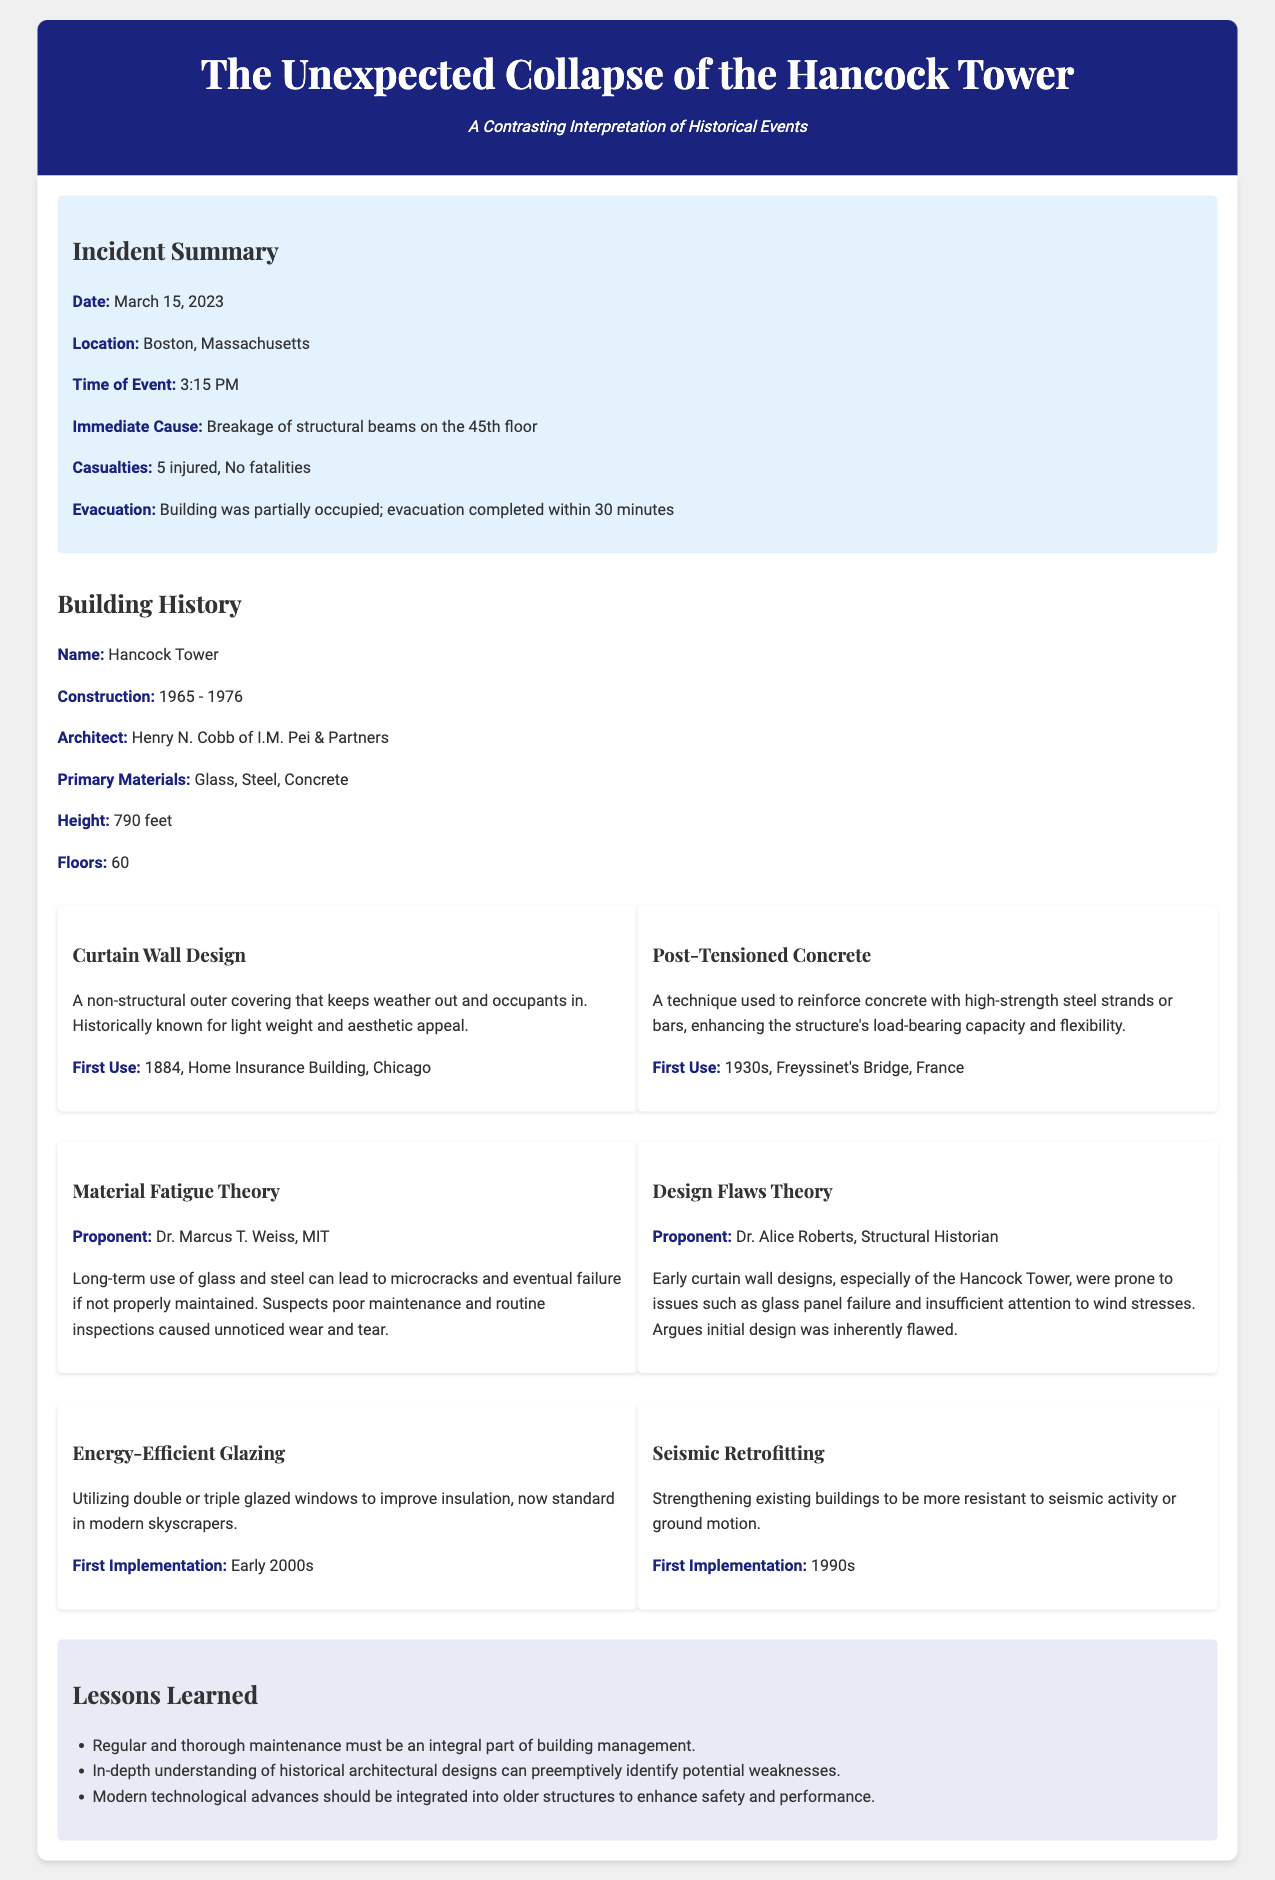What was the date of the incident? The date mentioned in the incident report is March 15, 2023.
Answer: March 15, 2023 Who was the architect of the Hancock Tower? The document states that the architect is Henry N. Cobb of I.M. Pei & Partners.
Answer: Henry N. Cobb What was the immediate cause of the collapse? According to the report, the immediate cause was the breakage of structural beams on the 45th floor.
Answer: Breakage of structural beams on the 45th floor What theory does Dr. Marcus T. Weiss propose? The document indicates that Dr. Marcus T. Weiss supports the Material Fatigue Theory.
Answer: Material Fatigue Theory What were the primary materials used in the construction of the Hancock Tower? The report mentions that the primary materials were glass, steel, and concrete.
Answer: Glass, Steel, Concrete Which modern influence first implemented in the early 2000s is mentioned in the report? The report discusses energy-efficient glazing as a modern influence first implemented in the early 2000s.
Answer: Energy-Efficient Glazing What was the total number of casualties reported? The incident report specifies that there were 5 injured, with no fatalities reported.
Answer: 5 injured What is one lesson learned highlighted in the document? The report highlights that regular and thorough maintenance must be an integral part of building management as a lesson learned.
Answer: Regular and thorough maintenance Which historical technique was first used in the Home Insurance Building? According to the document, the curtain wall design was first used in the Home Insurance Building.
Answer: Curtain Wall Design 